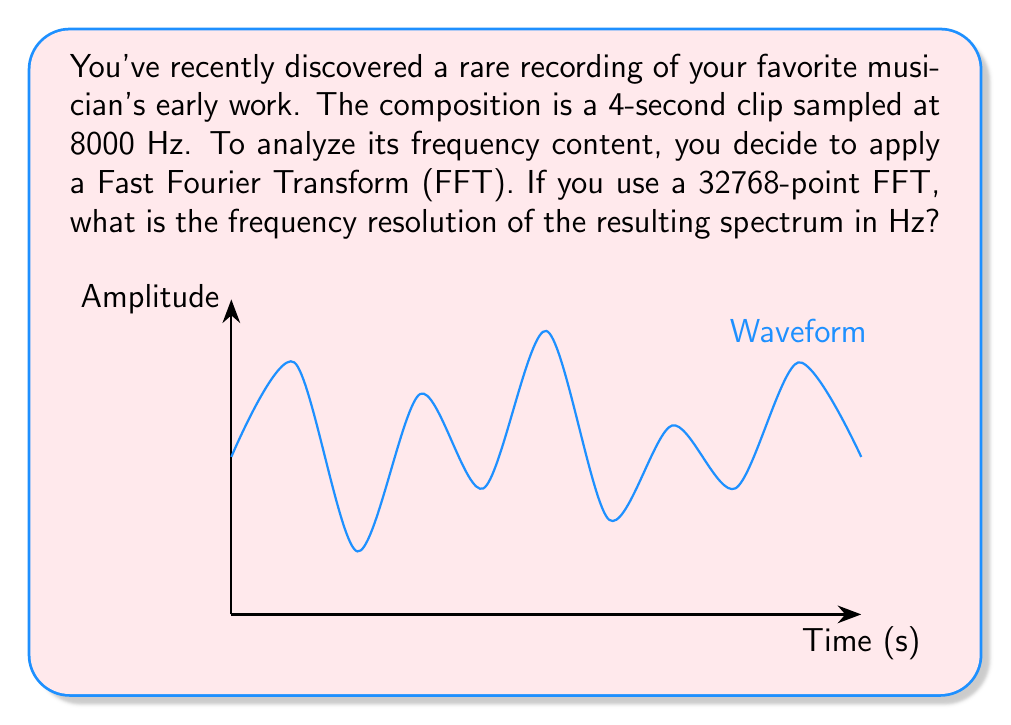What is the answer to this math problem? To solve this problem, we need to understand the relationship between the FFT size, sampling rate, and frequency resolution. Let's break it down step-by-step:

1) The frequency resolution (Δf) of an FFT is given by the formula:

   $$\Delta f = \frac{f_s}{N}$$

   Where $f_s$ is the sampling frequency and $N$ is the number of points in the FFT.

2) We are given:
   - Sampling frequency, $f_s = 8000$ Hz
   - FFT size, $N = 32768$ points

3) Substituting these values into the formula:

   $$\Delta f = \frac{8000 \text{ Hz}}{32768}$$

4) Simplifying:
   
   $$\Delta f = 0.244140625 \text{ Hz}$$

5) Rounding to three decimal places for a more practical representation:

   $$\Delta f \approx 0.244 \text{ Hz}$$

This means that each bin in the frequency spectrum will represent a bandwidth of approximately 0.244 Hz.
Answer: 0.244 Hz 